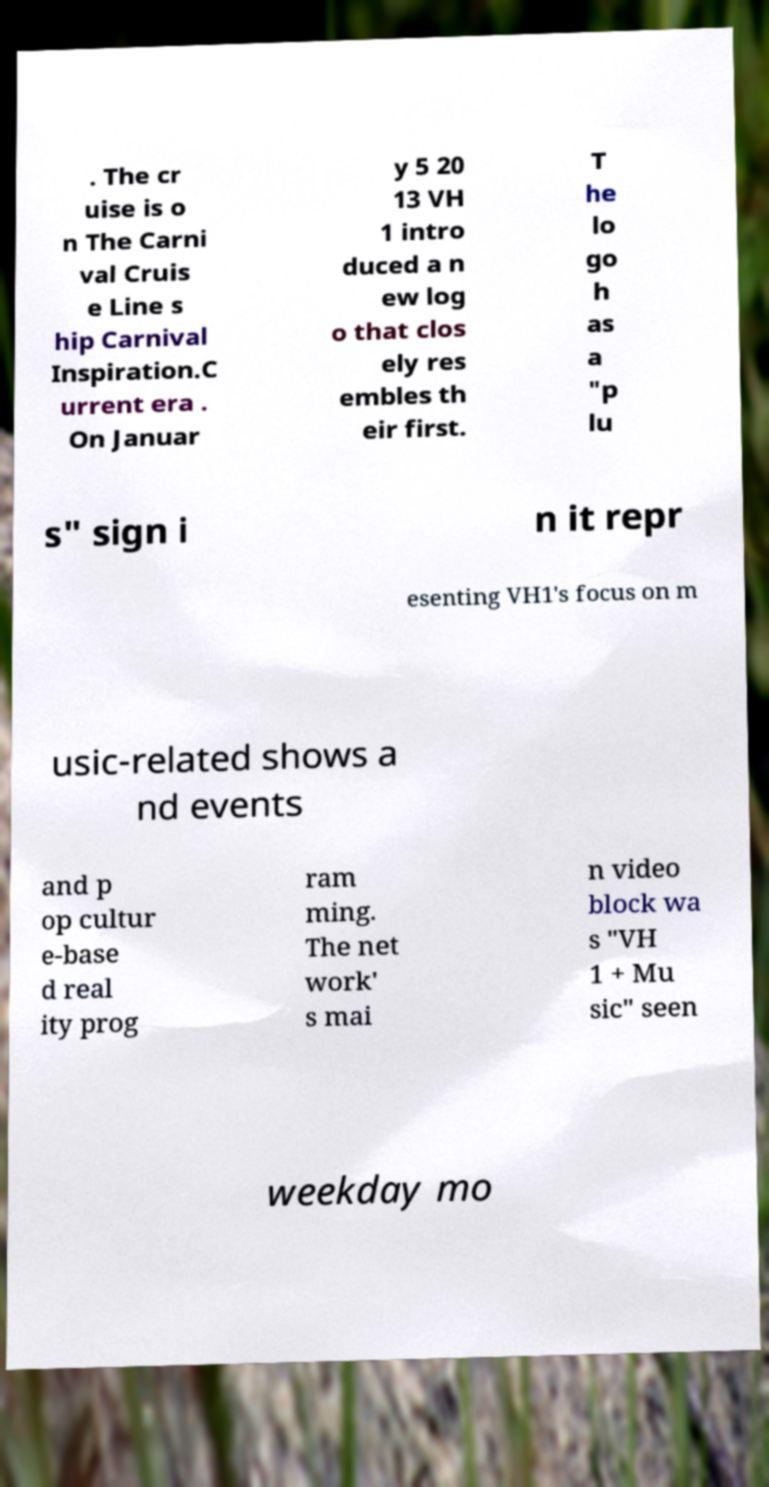Could you extract and type out the text from this image? . The cr uise is o n The Carni val Cruis e Line s hip Carnival Inspiration.C urrent era . On Januar y 5 20 13 VH 1 intro duced a n ew log o that clos ely res embles th eir first. T he lo go h as a "p lu s" sign i n it repr esenting VH1's focus on m usic-related shows a nd events and p op cultur e-base d real ity prog ram ming. The net work' s mai n video block wa s "VH 1 + Mu sic" seen weekday mo 